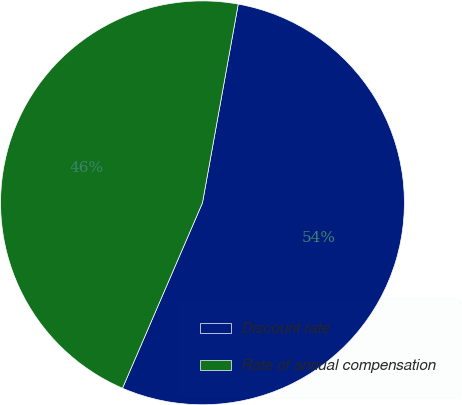Convert chart. <chart><loc_0><loc_0><loc_500><loc_500><pie_chart><fcel>Discount rate<fcel>Rate of annual compensation<nl><fcel>53.65%<fcel>46.35%<nl></chart> 